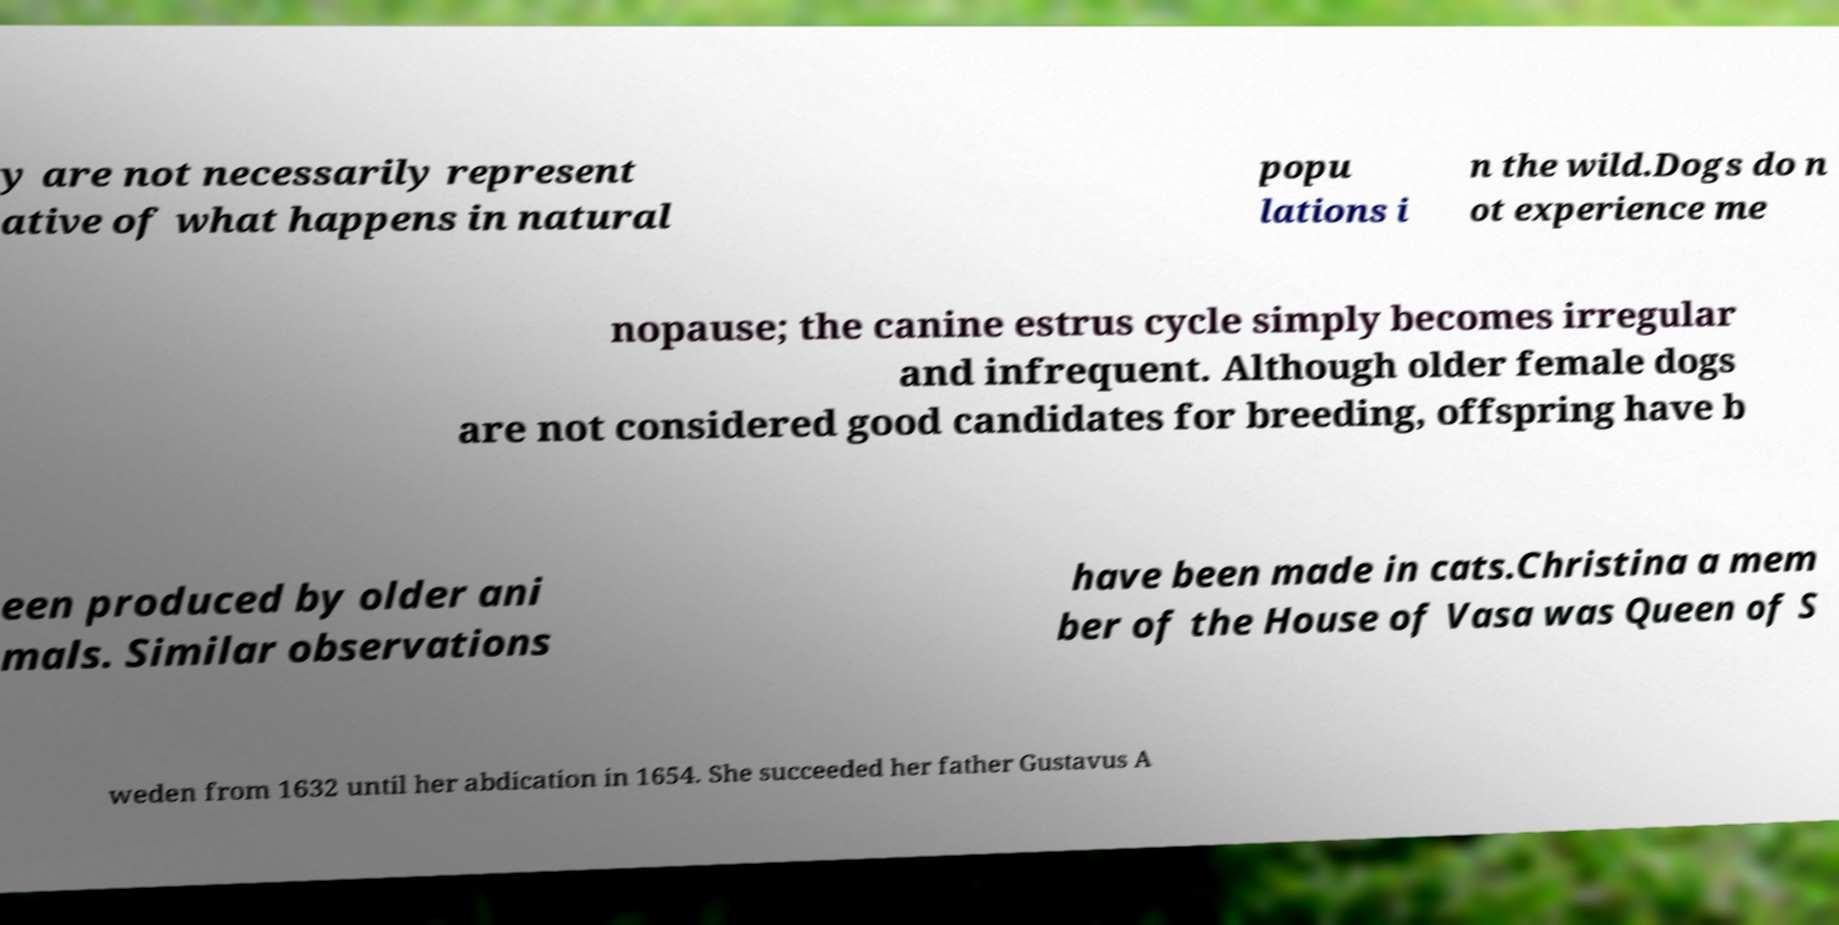Please read and relay the text visible in this image. What does it say? y are not necessarily represent ative of what happens in natural popu lations i n the wild.Dogs do n ot experience me nopause; the canine estrus cycle simply becomes irregular and infrequent. Although older female dogs are not considered good candidates for breeding, offspring have b een produced by older ani mals. Similar observations have been made in cats.Christina a mem ber of the House of Vasa was Queen of S weden from 1632 until her abdication in 1654. She succeeded her father Gustavus A 